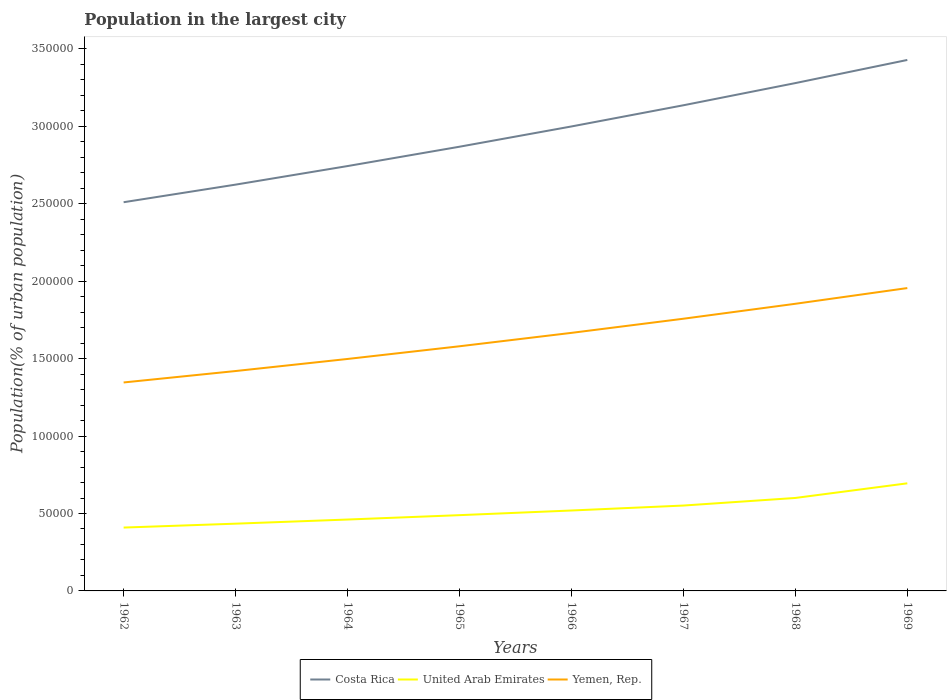Does the line corresponding to United Arab Emirates intersect with the line corresponding to Yemen, Rep.?
Your answer should be compact. No. Is the number of lines equal to the number of legend labels?
Your answer should be compact. Yes. Across all years, what is the maximum population in the largest city in Yemen, Rep.?
Your answer should be compact. 1.35e+05. What is the total population in the largest city in Yemen, Rep. in the graph?
Make the answer very short. -3.20e+04. What is the difference between the highest and the second highest population in the largest city in Yemen, Rep.?
Ensure brevity in your answer.  6.10e+04. What is the difference between the highest and the lowest population in the largest city in United Arab Emirates?
Provide a short and direct response. 3. Is the population in the largest city in Yemen, Rep. strictly greater than the population in the largest city in Costa Rica over the years?
Provide a short and direct response. Yes. How many lines are there?
Your response must be concise. 3. How many years are there in the graph?
Offer a terse response. 8. Does the graph contain any zero values?
Your response must be concise. No. Does the graph contain grids?
Make the answer very short. No. What is the title of the graph?
Make the answer very short. Population in the largest city. What is the label or title of the Y-axis?
Give a very brief answer. Population(% of urban population). What is the Population(% of urban population) of Costa Rica in 1962?
Offer a terse response. 2.51e+05. What is the Population(% of urban population) in United Arab Emirates in 1962?
Give a very brief answer. 4.09e+04. What is the Population(% of urban population) in Yemen, Rep. in 1962?
Your answer should be compact. 1.35e+05. What is the Population(% of urban population) of Costa Rica in 1963?
Provide a succinct answer. 2.62e+05. What is the Population(% of urban population) in United Arab Emirates in 1963?
Provide a short and direct response. 4.34e+04. What is the Population(% of urban population) of Yemen, Rep. in 1963?
Provide a succinct answer. 1.42e+05. What is the Population(% of urban population) of Costa Rica in 1964?
Make the answer very short. 2.74e+05. What is the Population(% of urban population) in United Arab Emirates in 1964?
Offer a very short reply. 4.61e+04. What is the Population(% of urban population) in Yemen, Rep. in 1964?
Provide a short and direct response. 1.50e+05. What is the Population(% of urban population) of Costa Rica in 1965?
Your answer should be compact. 2.87e+05. What is the Population(% of urban population) in United Arab Emirates in 1965?
Keep it short and to the point. 4.89e+04. What is the Population(% of urban population) in Yemen, Rep. in 1965?
Offer a very short reply. 1.58e+05. What is the Population(% of urban population) of Costa Rica in 1966?
Keep it short and to the point. 3.00e+05. What is the Population(% of urban population) in United Arab Emirates in 1966?
Provide a succinct answer. 5.19e+04. What is the Population(% of urban population) in Yemen, Rep. in 1966?
Keep it short and to the point. 1.67e+05. What is the Population(% of urban population) in Costa Rica in 1967?
Your answer should be compact. 3.14e+05. What is the Population(% of urban population) of United Arab Emirates in 1967?
Provide a short and direct response. 5.51e+04. What is the Population(% of urban population) of Yemen, Rep. in 1967?
Ensure brevity in your answer.  1.76e+05. What is the Population(% of urban population) of Costa Rica in 1968?
Your answer should be very brief. 3.28e+05. What is the Population(% of urban population) of United Arab Emirates in 1968?
Provide a short and direct response. 6.00e+04. What is the Population(% of urban population) of Yemen, Rep. in 1968?
Keep it short and to the point. 1.85e+05. What is the Population(% of urban population) in Costa Rica in 1969?
Provide a succinct answer. 3.43e+05. What is the Population(% of urban population) in United Arab Emirates in 1969?
Provide a succinct answer. 6.95e+04. What is the Population(% of urban population) in Yemen, Rep. in 1969?
Your response must be concise. 1.96e+05. Across all years, what is the maximum Population(% of urban population) of Costa Rica?
Provide a short and direct response. 3.43e+05. Across all years, what is the maximum Population(% of urban population) of United Arab Emirates?
Your answer should be very brief. 6.95e+04. Across all years, what is the maximum Population(% of urban population) in Yemen, Rep.?
Your response must be concise. 1.96e+05. Across all years, what is the minimum Population(% of urban population) in Costa Rica?
Provide a short and direct response. 2.51e+05. Across all years, what is the minimum Population(% of urban population) in United Arab Emirates?
Ensure brevity in your answer.  4.09e+04. Across all years, what is the minimum Population(% of urban population) of Yemen, Rep.?
Give a very brief answer. 1.35e+05. What is the total Population(% of urban population) in Costa Rica in the graph?
Make the answer very short. 2.36e+06. What is the total Population(% of urban population) in United Arab Emirates in the graph?
Your response must be concise. 4.16e+05. What is the total Population(% of urban population) of Yemen, Rep. in the graph?
Offer a very short reply. 1.31e+06. What is the difference between the Population(% of urban population) of Costa Rica in 1962 and that in 1963?
Provide a short and direct response. -1.14e+04. What is the difference between the Population(% of urban population) in United Arab Emirates in 1962 and that in 1963?
Your answer should be compact. -2514. What is the difference between the Population(% of urban population) of Yemen, Rep. in 1962 and that in 1963?
Your response must be concise. -7377. What is the difference between the Population(% of urban population) in Costa Rica in 1962 and that in 1964?
Your answer should be compact. -2.33e+04. What is the difference between the Population(% of urban population) in United Arab Emirates in 1962 and that in 1964?
Provide a succinct answer. -5187. What is the difference between the Population(% of urban population) of Yemen, Rep. in 1962 and that in 1964?
Make the answer very short. -1.52e+04. What is the difference between the Population(% of urban population) of Costa Rica in 1962 and that in 1965?
Give a very brief answer. -3.58e+04. What is the difference between the Population(% of urban population) in United Arab Emirates in 1962 and that in 1965?
Provide a succinct answer. -8016. What is the difference between the Population(% of urban population) in Yemen, Rep. in 1962 and that in 1965?
Provide a succinct answer. -2.34e+04. What is the difference between the Population(% of urban population) in Costa Rica in 1962 and that in 1966?
Ensure brevity in your answer.  -4.89e+04. What is the difference between the Population(% of urban population) of United Arab Emirates in 1962 and that in 1966?
Provide a succinct answer. -1.10e+04. What is the difference between the Population(% of urban population) in Yemen, Rep. in 1962 and that in 1966?
Your answer should be compact. -3.20e+04. What is the difference between the Population(% of urban population) of Costa Rica in 1962 and that in 1967?
Give a very brief answer. -6.26e+04. What is the difference between the Population(% of urban population) of United Arab Emirates in 1962 and that in 1967?
Make the answer very short. -1.42e+04. What is the difference between the Population(% of urban population) in Yemen, Rep. in 1962 and that in 1967?
Provide a short and direct response. -4.12e+04. What is the difference between the Population(% of urban population) in Costa Rica in 1962 and that in 1968?
Your answer should be compact. -7.69e+04. What is the difference between the Population(% of urban population) of United Arab Emirates in 1962 and that in 1968?
Provide a short and direct response. -1.91e+04. What is the difference between the Population(% of urban population) in Yemen, Rep. in 1962 and that in 1968?
Ensure brevity in your answer.  -5.08e+04. What is the difference between the Population(% of urban population) in Costa Rica in 1962 and that in 1969?
Your response must be concise. -9.19e+04. What is the difference between the Population(% of urban population) in United Arab Emirates in 1962 and that in 1969?
Offer a very short reply. -2.86e+04. What is the difference between the Population(% of urban population) of Yemen, Rep. in 1962 and that in 1969?
Make the answer very short. -6.10e+04. What is the difference between the Population(% of urban population) of Costa Rica in 1963 and that in 1964?
Your answer should be very brief. -1.20e+04. What is the difference between the Population(% of urban population) of United Arab Emirates in 1963 and that in 1964?
Your response must be concise. -2673. What is the difference between the Population(% of urban population) of Yemen, Rep. in 1963 and that in 1964?
Make the answer very short. -7793. What is the difference between the Population(% of urban population) of Costa Rica in 1963 and that in 1965?
Give a very brief answer. -2.45e+04. What is the difference between the Population(% of urban population) in United Arab Emirates in 1963 and that in 1965?
Your answer should be very brief. -5502. What is the difference between the Population(% of urban population) in Yemen, Rep. in 1963 and that in 1965?
Provide a succinct answer. -1.60e+04. What is the difference between the Population(% of urban population) in Costa Rica in 1963 and that in 1966?
Give a very brief answer. -3.76e+04. What is the difference between the Population(% of urban population) in United Arab Emirates in 1963 and that in 1966?
Provide a succinct answer. -8509. What is the difference between the Population(% of urban population) of Yemen, Rep. in 1963 and that in 1966?
Offer a very short reply. -2.46e+04. What is the difference between the Population(% of urban population) of Costa Rica in 1963 and that in 1967?
Provide a short and direct response. -5.12e+04. What is the difference between the Population(% of urban population) of United Arab Emirates in 1963 and that in 1967?
Provide a short and direct response. -1.17e+04. What is the difference between the Population(% of urban population) in Yemen, Rep. in 1963 and that in 1967?
Your answer should be very brief. -3.38e+04. What is the difference between the Population(% of urban population) of Costa Rica in 1963 and that in 1968?
Ensure brevity in your answer.  -6.56e+04. What is the difference between the Population(% of urban population) of United Arab Emirates in 1963 and that in 1968?
Make the answer very short. -1.66e+04. What is the difference between the Population(% of urban population) of Yemen, Rep. in 1963 and that in 1968?
Give a very brief answer. -4.34e+04. What is the difference between the Population(% of urban population) of Costa Rica in 1963 and that in 1969?
Keep it short and to the point. -8.05e+04. What is the difference between the Population(% of urban population) of United Arab Emirates in 1963 and that in 1969?
Offer a terse response. -2.61e+04. What is the difference between the Population(% of urban population) of Yemen, Rep. in 1963 and that in 1969?
Your response must be concise. -5.36e+04. What is the difference between the Population(% of urban population) in Costa Rica in 1964 and that in 1965?
Ensure brevity in your answer.  -1.25e+04. What is the difference between the Population(% of urban population) in United Arab Emirates in 1964 and that in 1965?
Provide a succinct answer. -2829. What is the difference between the Population(% of urban population) in Yemen, Rep. in 1964 and that in 1965?
Your response must be concise. -8197. What is the difference between the Population(% of urban population) of Costa Rica in 1964 and that in 1966?
Offer a very short reply. -2.56e+04. What is the difference between the Population(% of urban population) in United Arab Emirates in 1964 and that in 1966?
Give a very brief answer. -5836. What is the difference between the Population(% of urban population) in Yemen, Rep. in 1964 and that in 1966?
Keep it short and to the point. -1.69e+04. What is the difference between the Population(% of urban population) in Costa Rica in 1964 and that in 1967?
Keep it short and to the point. -3.93e+04. What is the difference between the Population(% of urban population) of United Arab Emirates in 1964 and that in 1967?
Your response must be concise. -9028. What is the difference between the Population(% of urban population) in Yemen, Rep. in 1964 and that in 1967?
Provide a succinct answer. -2.60e+04. What is the difference between the Population(% of urban population) of Costa Rica in 1964 and that in 1968?
Your answer should be compact. -5.36e+04. What is the difference between the Population(% of urban population) in United Arab Emirates in 1964 and that in 1968?
Make the answer very short. -1.39e+04. What is the difference between the Population(% of urban population) in Yemen, Rep. in 1964 and that in 1968?
Keep it short and to the point. -3.56e+04. What is the difference between the Population(% of urban population) of Costa Rica in 1964 and that in 1969?
Offer a very short reply. -6.85e+04. What is the difference between the Population(% of urban population) of United Arab Emirates in 1964 and that in 1969?
Keep it short and to the point. -2.34e+04. What is the difference between the Population(% of urban population) in Yemen, Rep. in 1964 and that in 1969?
Your response must be concise. -4.58e+04. What is the difference between the Population(% of urban population) in Costa Rica in 1965 and that in 1966?
Give a very brief answer. -1.31e+04. What is the difference between the Population(% of urban population) of United Arab Emirates in 1965 and that in 1966?
Provide a succinct answer. -3007. What is the difference between the Population(% of urban population) in Yemen, Rep. in 1965 and that in 1966?
Your response must be concise. -8658. What is the difference between the Population(% of urban population) of Costa Rica in 1965 and that in 1967?
Offer a terse response. -2.68e+04. What is the difference between the Population(% of urban population) of United Arab Emirates in 1965 and that in 1967?
Offer a terse response. -6199. What is the difference between the Population(% of urban population) in Yemen, Rep. in 1965 and that in 1967?
Ensure brevity in your answer.  -1.78e+04. What is the difference between the Population(% of urban population) of Costa Rica in 1965 and that in 1968?
Your response must be concise. -4.11e+04. What is the difference between the Population(% of urban population) in United Arab Emirates in 1965 and that in 1968?
Your answer should be compact. -1.11e+04. What is the difference between the Population(% of urban population) of Yemen, Rep. in 1965 and that in 1968?
Ensure brevity in your answer.  -2.74e+04. What is the difference between the Population(% of urban population) of Costa Rica in 1965 and that in 1969?
Keep it short and to the point. -5.60e+04. What is the difference between the Population(% of urban population) in United Arab Emirates in 1965 and that in 1969?
Ensure brevity in your answer.  -2.06e+04. What is the difference between the Population(% of urban population) in Yemen, Rep. in 1965 and that in 1969?
Provide a succinct answer. -3.76e+04. What is the difference between the Population(% of urban population) in Costa Rica in 1966 and that in 1967?
Provide a succinct answer. -1.37e+04. What is the difference between the Population(% of urban population) in United Arab Emirates in 1966 and that in 1967?
Your response must be concise. -3192. What is the difference between the Population(% of urban population) of Yemen, Rep. in 1966 and that in 1967?
Your answer should be compact. -9132. What is the difference between the Population(% of urban population) in Costa Rica in 1966 and that in 1968?
Your answer should be very brief. -2.80e+04. What is the difference between the Population(% of urban population) of United Arab Emirates in 1966 and that in 1968?
Your answer should be compact. -8101. What is the difference between the Population(% of urban population) in Yemen, Rep. in 1966 and that in 1968?
Your response must be concise. -1.88e+04. What is the difference between the Population(% of urban population) of Costa Rica in 1966 and that in 1969?
Your answer should be compact. -4.29e+04. What is the difference between the Population(% of urban population) in United Arab Emirates in 1966 and that in 1969?
Ensure brevity in your answer.  -1.75e+04. What is the difference between the Population(% of urban population) in Yemen, Rep. in 1966 and that in 1969?
Keep it short and to the point. -2.89e+04. What is the difference between the Population(% of urban population) in Costa Rica in 1967 and that in 1968?
Give a very brief answer. -1.43e+04. What is the difference between the Population(% of urban population) in United Arab Emirates in 1967 and that in 1968?
Your answer should be very brief. -4909. What is the difference between the Population(% of urban population) in Yemen, Rep. in 1967 and that in 1968?
Make the answer very short. -9647. What is the difference between the Population(% of urban population) in Costa Rica in 1967 and that in 1969?
Your answer should be compact. -2.93e+04. What is the difference between the Population(% of urban population) in United Arab Emirates in 1967 and that in 1969?
Your answer should be very brief. -1.44e+04. What is the difference between the Population(% of urban population) in Yemen, Rep. in 1967 and that in 1969?
Keep it short and to the point. -1.98e+04. What is the difference between the Population(% of urban population) in Costa Rica in 1968 and that in 1969?
Keep it short and to the point. -1.49e+04. What is the difference between the Population(% of urban population) of United Arab Emirates in 1968 and that in 1969?
Your response must be concise. -9448. What is the difference between the Population(% of urban population) of Yemen, Rep. in 1968 and that in 1969?
Ensure brevity in your answer.  -1.01e+04. What is the difference between the Population(% of urban population) of Costa Rica in 1962 and the Population(% of urban population) of United Arab Emirates in 1963?
Your answer should be very brief. 2.08e+05. What is the difference between the Population(% of urban population) in Costa Rica in 1962 and the Population(% of urban population) in Yemen, Rep. in 1963?
Keep it short and to the point. 1.09e+05. What is the difference between the Population(% of urban population) in United Arab Emirates in 1962 and the Population(% of urban population) in Yemen, Rep. in 1963?
Keep it short and to the point. -1.01e+05. What is the difference between the Population(% of urban population) in Costa Rica in 1962 and the Population(% of urban population) in United Arab Emirates in 1964?
Your answer should be compact. 2.05e+05. What is the difference between the Population(% of urban population) in Costa Rica in 1962 and the Population(% of urban population) in Yemen, Rep. in 1964?
Your answer should be very brief. 1.01e+05. What is the difference between the Population(% of urban population) in United Arab Emirates in 1962 and the Population(% of urban population) in Yemen, Rep. in 1964?
Your response must be concise. -1.09e+05. What is the difference between the Population(% of urban population) in Costa Rica in 1962 and the Population(% of urban population) in United Arab Emirates in 1965?
Provide a short and direct response. 2.02e+05. What is the difference between the Population(% of urban population) in Costa Rica in 1962 and the Population(% of urban population) in Yemen, Rep. in 1965?
Give a very brief answer. 9.30e+04. What is the difference between the Population(% of urban population) of United Arab Emirates in 1962 and the Population(% of urban population) of Yemen, Rep. in 1965?
Make the answer very short. -1.17e+05. What is the difference between the Population(% of urban population) in Costa Rica in 1962 and the Population(% of urban population) in United Arab Emirates in 1966?
Keep it short and to the point. 1.99e+05. What is the difference between the Population(% of urban population) in Costa Rica in 1962 and the Population(% of urban population) in Yemen, Rep. in 1966?
Keep it short and to the point. 8.44e+04. What is the difference between the Population(% of urban population) of United Arab Emirates in 1962 and the Population(% of urban population) of Yemen, Rep. in 1966?
Offer a terse response. -1.26e+05. What is the difference between the Population(% of urban population) of Costa Rica in 1962 and the Population(% of urban population) of United Arab Emirates in 1967?
Offer a very short reply. 1.96e+05. What is the difference between the Population(% of urban population) in Costa Rica in 1962 and the Population(% of urban population) in Yemen, Rep. in 1967?
Ensure brevity in your answer.  7.52e+04. What is the difference between the Population(% of urban population) in United Arab Emirates in 1962 and the Population(% of urban population) in Yemen, Rep. in 1967?
Keep it short and to the point. -1.35e+05. What is the difference between the Population(% of urban population) in Costa Rica in 1962 and the Population(% of urban population) in United Arab Emirates in 1968?
Offer a very short reply. 1.91e+05. What is the difference between the Population(% of urban population) of Costa Rica in 1962 and the Population(% of urban population) of Yemen, Rep. in 1968?
Your answer should be very brief. 6.56e+04. What is the difference between the Population(% of urban population) of United Arab Emirates in 1962 and the Population(% of urban population) of Yemen, Rep. in 1968?
Provide a short and direct response. -1.45e+05. What is the difference between the Population(% of urban population) of Costa Rica in 1962 and the Population(% of urban population) of United Arab Emirates in 1969?
Your answer should be very brief. 1.82e+05. What is the difference between the Population(% of urban population) in Costa Rica in 1962 and the Population(% of urban population) in Yemen, Rep. in 1969?
Give a very brief answer. 5.54e+04. What is the difference between the Population(% of urban population) of United Arab Emirates in 1962 and the Population(% of urban population) of Yemen, Rep. in 1969?
Offer a very short reply. -1.55e+05. What is the difference between the Population(% of urban population) of Costa Rica in 1963 and the Population(% of urban population) of United Arab Emirates in 1964?
Offer a very short reply. 2.16e+05. What is the difference between the Population(% of urban population) in Costa Rica in 1963 and the Population(% of urban population) in Yemen, Rep. in 1964?
Your response must be concise. 1.13e+05. What is the difference between the Population(% of urban population) in United Arab Emirates in 1963 and the Population(% of urban population) in Yemen, Rep. in 1964?
Make the answer very short. -1.06e+05. What is the difference between the Population(% of urban population) of Costa Rica in 1963 and the Population(% of urban population) of United Arab Emirates in 1965?
Provide a succinct answer. 2.13e+05. What is the difference between the Population(% of urban population) in Costa Rica in 1963 and the Population(% of urban population) in Yemen, Rep. in 1965?
Give a very brief answer. 1.04e+05. What is the difference between the Population(% of urban population) in United Arab Emirates in 1963 and the Population(% of urban population) in Yemen, Rep. in 1965?
Your response must be concise. -1.15e+05. What is the difference between the Population(% of urban population) of Costa Rica in 1963 and the Population(% of urban population) of United Arab Emirates in 1966?
Your response must be concise. 2.10e+05. What is the difference between the Population(% of urban population) in Costa Rica in 1963 and the Population(% of urban population) in Yemen, Rep. in 1966?
Provide a succinct answer. 9.57e+04. What is the difference between the Population(% of urban population) of United Arab Emirates in 1963 and the Population(% of urban population) of Yemen, Rep. in 1966?
Offer a terse response. -1.23e+05. What is the difference between the Population(% of urban population) of Costa Rica in 1963 and the Population(% of urban population) of United Arab Emirates in 1967?
Make the answer very short. 2.07e+05. What is the difference between the Population(% of urban population) of Costa Rica in 1963 and the Population(% of urban population) of Yemen, Rep. in 1967?
Offer a terse response. 8.66e+04. What is the difference between the Population(% of urban population) in United Arab Emirates in 1963 and the Population(% of urban population) in Yemen, Rep. in 1967?
Make the answer very short. -1.32e+05. What is the difference between the Population(% of urban population) of Costa Rica in 1963 and the Population(% of urban population) of United Arab Emirates in 1968?
Offer a very short reply. 2.02e+05. What is the difference between the Population(% of urban population) of Costa Rica in 1963 and the Population(% of urban population) of Yemen, Rep. in 1968?
Provide a short and direct response. 7.69e+04. What is the difference between the Population(% of urban population) of United Arab Emirates in 1963 and the Population(% of urban population) of Yemen, Rep. in 1968?
Your answer should be compact. -1.42e+05. What is the difference between the Population(% of urban population) in Costa Rica in 1963 and the Population(% of urban population) in United Arab Emirates in 1969?
Provide a succinct answer. 1.93e+05. What is the difference between the Population(% of urban population) in Costa Rica in 1963 and the Population(% of urban population) in Yemen, Rep. in 1969?
Keep it short and to the point. 6.68e+04. What is the difference between the Population(% of urban population) of United Arab Emirates in 1963 and the Population(% of urban population) of Yemen, Rep. in 1969?
Your answer should be very brief. -1.52e+05. What is the difference between the Population(% of urban population) in Costa Rica in 1964 and the Population(% of urban population) in United Arab Emirates in 1965?
Provide a succinct answer. 2.25e+05. What is the difference between the Population(% of urban population) of Costa Rica in 1964 and the Population(% of urban population) of Yemen, Rep. in 1965?
Offer a terse response. 1.16e+05. What is the difference between the Population(% of urban population) of United Arab Emirates in 1964 and the Population(% of urban population) of Yemen, Rep. in 1965?
Make the answer very short. -1.12e+05. What is the difference between the Population(% of urban population) of Costa Rica in 1964 and the Population(% of urban population) of United Arab Emirates in 1966?
Offer a very short reply. 2.22e+05. What is the difference between the Population(% of urban population) in Costa Rica in 1964 and the Population(% of urban population) in Yemen, Rep. in 1966?
Offer a very short reply. 1.08e+05. What is the difference between the Population(% of urban population) in United Arab Emirates in 1964 and the Population(% of urban population) in Yemen, Rep. in 1966?
Make the answer very short. -1.21e+05. What is the difference between the Population(% of urban population) of Costa Rica in 1964 and the Population(% of urban population) of United Arab Emirates in 1967?
Keep it short and to the point. 2.19e+05. What is the difference between the Population(% of urban population) in Costa Rica in 1964 and the Population(% of urban population) in Yemen, Rep. in 1967?
Give a very brief answer. 9.86e+04. What is the difference between the Population(% of urban population) of United Arab Emirates in 1964 and the Population(% of urban population) of Yemen, Rep. in 1967?
Offer a terse response. -1.30e+05. What is the difference between the Population(% of urban population) of Costa Rica in 1964 and the Population(% of urban population) of United Arab Emirates in 1968?
Provide a succinct answer. 2.14e+05. What is the difference between the Population(% of urban population) of Costa Rica in 1964 and the Population(% of urban population) of Yemen, Rep. in 1968?
Give a very brief answer. 8.89e+04. What is the difference between the Population(% of urban population) of United Arab Emirates in 1964 and the Population(% of urban population) of Yemen, Rep. in 1968?
Offer a very short reply. -1.39e+05. What is the difference between the Population(% of urban population) of Costa Rica in 1964 and the Population(% of urban population) of United Arab Emirates in 1969?
Offer a very short reply. 2.05e+05. What is the difference between the Population(% of urban population) of Costa Rica in 1964 and the Population(% of urban population) of Yemen, Rep. in 1969?
Give a very brief answer. 7.88e+04. What is the difference between the Population(% of urban population) in United Arab Emirates in 1964 and the Population(% of urban population) in Yemen, Rep. in 1969?
Give a very brief answer. -1.49e+05. What is the difference between the Population(% of urban population) in Costa Rica in 1965 and the Population(% of urban population) in United Arab Emirates in 1966?
Your answer should be very brief. 2.35e+05. What is the difference between the Population(% of urban population) of Costa Rica in 1965 and the Population(% of urban population) of Yemen, Rep. in 1966?
Ensure brevity in your answer.  1.20e+05. What is the difference between the Population(% of urban population) of United Arab Emirates in 1965 and the Population(% of urban population) of Yemen, Rep. in 1966?
Provide a succinct answer. -1.18e+05. What is the difference between the Population(% of urban population) of Costa Rica in 1965 and the Population(% of urban population) of United Arab Emirates in 1967?
Ensure brevity in your answer.  2.32e+05. What is the difference between the Population(% of urban population) in Costa Rica in 1965 and the Population(% of urban population) in Yemen, Rep. in 1967?
Make the answer very short. 1.11e+05. What is the difference between the Population(% of urban population) in United Arab Emirates in 1965 and the Population(% of urban population) in Yemen, Rep. in 1967?
Provide a short and direct response. -1.27e+05. What is the difference between the Population(% of urban population) of Costa Rica in 1965 and the Population(% of urban population) of United Arab Emirates in 1968?
Ensure brevity in your answer.  2.27e+05. What is the difference between the Population(% of urban population) in Costa Rica in 1965 and the Population(% of urban population) in Yemen, Rep. in 1968?
Keep it short and to the point. 1.01e+05. What is the difference between the Population(% of urban population) of United Arab Emirates in 1965 and the Population(% of urban population) of Yemen, Rep. in 1968?
Offer a terse response. -1.36e+05. What is the difference between the Population(% of urban population) of Costa Rica in 1965 and the Population(% of urban population) of United Arab Emirates in 1969?
Ensure brevity in your answer.  2.17e+05. What is the difference between the Population(% of urban population) in Costa Rica in 1965 and the Population(% of urban population) in Yemen, Rep. in 1969?
Keep it short and to the point. 9.13e+04. What is the difference between the Population(% of urban population) in United Arab Emirates in 1965 and the Population(% of urban population) in Yemen, Rep. in 1969?
Your answer should be very brief. -1.47e+05. What is the difference between the Population(% of urban population) of Costa Rica in 1966 and the Population(% of urban population) of United Arab Emirates in 1967?
Your answer should be compact. 2.45e+05. What is the difference between the Population(% of urban population) in Costa Rica in 1966 and the Population(% of urban population) in Yemen, Rep. in 1967?
Your response must be concise. 1.24e+05. What is the difference between the Population(% of urban population) of United Arab Emirates in 1966 and the Population(% of urban population) of Yemen, Rep. in 1967?
Provide a short and direct response. -1.24e+05. What is the difference between the Population(% of urban population) in Costa Rica in 1966 and the Population(% of urban population) in United Arab Emirates in 1968?
Keep it short and to the point. 2.40e+05. What is the difference between the Population(% of urban population) in Costa Rica in 1966 and the Population(% of urban population) in Yemen, Rep. in 1968?
Your answer should be very brief. 1.15e+05. What is the difference between the Population(% of urban population) in United Arab Emirates in 1966 and the Population(% of urban population) in Yemen, Rep. in 1968?
Your answer should be very brief. -1.33e+05. What is the difference between the Population(% of urban population) of Costa Rica in 1966 and the Population(% of urban population) of United Arab Emirates in 1969?
Offer a very short reply. 2.30e+05. What is the difference between the Population(% of urban population) of Costa Rica in 1966 and the Population(% of urban population) of Yemen, Rep. in 1969?
Keep it short and to the point. 1.04e+05. What is the difference between the Population(% of urban population) in United Arab Emirates in 1966 and the Population(% of urban population) in Yemen, Rep. in 1969?
Your answer should be very brief. -1.44e+05. What is the difference between the Population(% of urban population) of Costa Rica in 1967 and the Population(% of urban population) of United Arab Emirates in 1968?
Offer a terse response. 2.54e+05. What is the difference between the Population(% of urban population) of Costa Rica in 1967 and the Population(% of urban population) of Yemen, Rep. in 1968?
Your answer should be very brief. 1.28e+05. What is the difference between the Population(% of urban population) of United Arab Emirates in 1967 and the Population(% of urban population) of Yemen, Rep. in 1968?
Your response must be concise. -1.30e+05. What is the difference between the Population(% of urban population) in Costa Rica in 1967 and the Population(% of urban population) in United Arab Emirates in 1969?
Your response must be concise. 2.44e+05. What is the difference between the Population(% of urban population) of Costa Rica in 1967 and the Population(% of urban population) of Yemen, Rep. in 1969?
Make the answer very short. 1.18e+05. What is the difference between the Population(% of urban population) in United Arab Emirates in 1967 and the Population(% of urban population) in Yemen, Rep. in 1969?
Ensure brevity in your answer.  -1.40e+05. What is the difference between the Population(% of urban population) in Costa Rica in 1968 and the Population(% of urban population) in United Arab Emirates in 1969?
Make the answer very short. 2.58e+05. What is the difference between the Population(% of urban population) of Costa Rica in 1968 and the Population(% of urban population) of Yemen, Rep. in 1969?
Ensure brevity in your answer.  1.32e+05. What is the difference between the Population(% of urban population) of United Arab Emirates in 1968 and the Population(% of urban population) of Yemen, Rep. in 1969?
Keep it short and to the point. -1.36e+05. What is the average Population(% of urban population) of Costa Rica per year?
Your answer should be compact. 2.95e+05. What is the average Population(% of urban population) in United Arab Emirates per year?
Provide a succinct answer. 5.20e+04. What is the average Population(% of urban population) in Yemen, Rep. per year?
Make the answer very short. 1.63e+05. In the year 1962, what is the difference between the Population(% of urban population) of Costa Rica and Population(% of urban population) of United Arab Emirates?
Your answer should be compact. 2.10e+05. In the year 1962, what is the difference between the Population(% of urban population) in Costa Rica and Population(% of urban population) in Yemen, Rep.?
Provide a succinct answer. 1.16e+05. In the year 1962, what is the difference between the Population(% of urban population) in United Arab Emirates and Population(% of urban population) in Yemen, Rep.?
Offer a very short reply. -9.37e+04. In the year 1963, what is the difference between the Population(% of urban population) of Costa Rica and Population(% of urban population) of United Arab Emirates?
Keep it short and to the point. 2.19e+05. In the year 1963, what is the difference between the Population(% of urban population) in Costa Rica and Population(% of urban population) in Yemen, Rep.?
Provide a short and direct response. 1.20e+05. In the year 1963, what is the difference between the Population(% of urban population) in United Arab Emirates and Population(% of urban population) in Yemen, Rep.?
Keep it short and to the point. -9.86e+04. In the year 1964, what is the difference between the Population(% of urban population) in Costa Rica and Population(% of urban population) in United Arab Emirates?
Provide a short and direct response. 2.28e+05. In the year 1964, what is the difference between the Population(% of urban population) of Costa Rica and Population(% of urban population) of Yemen, Rep.?
Provide a succinct answer. 1.25e+05. In the year 1964, what is the difference between the Population(% of urban population) of United Arab Emirates and Population(% of urban population) of Yemen, Rep.?
Ensure brevity in your answer.  -1.04e+05. In the year 1965, what is the difference between the Population(% of urban population) in Costa Rica and Population(% of urban population) in United Arab Emirates?
Provide a succinct answer. 2.38e+05. In the year 1965, what is the difference between the Population(% of urban population) of Costa Rica and Population(% of urban population) of Yemen, Rep.?
Your response must be concise. 1.29e+05. In the year 1965, what is the difference between the Population(% of urban population) of United Arab Emirates and Population(% of urban population) of Yemen, Rep.?
Your answer should be compact. -1.09e+05. In the year 1966, what is the difference between the Population(% of urban population) of Costa Rica and Population(% of urban population) of United Arab Emirates?
Provide a short and direct response. 2.48e+05. In the year 1966, what is the difference between the Population(% of urban population) of Costa Rica and Population(% of urban population) of Yemen, Rep.?
Ensure brevity in your answer.  1.33e+05. In the year 1966, what is the difference between the Population(% of urban population) of United Arab Emirates and Population(% of urban population) of Yemen, Rep.?
Offer a terse response. -1.15e+05. In the year 1967, what is the difference between the Population(% of urban population) of Costa Rica and Population(% of urban population) of United Arab Emirates?
Offer a terse response. 2.58e+05. In the year 1967, what is the difference between the Population(% of urban population) of Costa Rica and Population(% of urban population) of Yemen, Rep.?
Give a very brief answer. 1.38e+05. In the year 1967, what is the difference between the Population(% of urban population) in United Arab Emirates and Population(% of urban population) in Yemen, Rep.?
Ensure brevity in your answer.  -1.21e+05. In the year 1968, what is the difference between the Population(% of urban population) of Costa Rica and Population(% of urban population) of United Arab Emirates?
Offer a very short reply. 2.68e+05. In the year 1968, what is the difference between the Population(% of urban population) of Costa Rica and Population(% of urban population) of Yemen, Rep.?
Ensure brevity in your answer.  1.43e+05. In the year 1968, what is the difference between the Population(% of urban population) of United Arab Emirates and Population(% of urban population) of Yemen, Rep.?
Offer a terse response. -1.25e+05. In the year 1969, what is the difference between the Population(% of urban population) of Costa Rica and Population(% of urban population) of United Arab Emirates?
Offer a very short reply. 2.73e+05. In the year 1969, what is the difference between the Population(% of urban population) in Costa Rica and Population(% of urban population) in Yemen, Rep.?
Your response must be concise. 1.47e+05. In the year 1969, what is the difference between the Population(% of urban population) in United Arab Emirates and Population(% of urban population) in Yemen, Rep.?
Provide a succinct answer. -1.26e+05. What is the ratio of the Population(% of urban population) in Costa Rica in 1962 to that in 1963?
Provide a succinct answer. 0.96. What is the ratio of the Population(% of urban population) of United Arab Emirates in 1962 to that in 1963?
Ensure brevity in your answer.  0.94. What is the ratio of the Population(% of urban population) of Yemen, Rep. in 1962 to that in 1963?
Provide a short and direct response. 0.95. What is the ratio of the Population(% of urban population) in Costa Rica in 1962 to that in 1964?
Keep it short and to the point. 0.91. What is the ratio of the Population(% of urban population) in United Arab Emirates in 1962 to that in 1964?
Give a very brief answer. 0.89. What is the ratio of the Population(% of urban population) in Yemen, Rep. in 1962 to that in 1964?
Provide a succinct answer. 0.9. What is the ratio of the Population(% of urban population) of United Arab Emirates in 1962 to that in 1965?
Provide a short and direct response. 0.84. What is the ratio of the Population(% of urban population) of Yemen, Rep. in 1962 to that in 1965?
Ensure brevity in your answer.  0.85. What is the ratio of the Population(% of urban population) in Costa Rica in 1962 to that in 1966?
Provide a succinct answer. 0.84. What is the ratio of the Population(% of urban population) in United Arab Emirates in 1962 to that in 1966?
Make the answer very short. 0.79. What is the ratio of the Population(% of urban population) of Yemen, Rep. in 1962 to that in 1966?
Provide a short and direct response. 0.81. What is the ratio of the Population(% of urban population) of Costa Rica in 1962 to that in 1967?
Offer a very short reply. 0.8. What is the ratio of the Population(% of urban population) of United Arab Emirates in 1962 to that in 1967?
Make the answer very short. 0.74. What is the ratio of the Population(% of urban population) in Yemen, Rep. in 1962 to that in 1967?
Keep it short and to the point. 0.77. What is the ratio of the Population(% of urban population) of Costa Rica in 1962 to that in 1968?
Offer a terse response. 0.77. What is the ratio of the Population(% of urban population) of United Arab Emirates in 1962 to that in 1968?
Give a very brief answer. 0.68. What is the ratio of the Population(% of urban population) in Yemen, Rep. in 1962 to that in 1968?
Your response must be concise. 0.73. What is the ratio of the Population(% of urban population) of Costa Rica in 1962 to that in 1969?
Offer a terse response. 0.73. What is the ratio of the Population(% of urban population) of United Arab Emirates in 1962 to that in 1969?
Your answer should be very brief. 0.59. What is the ratio of the Population(% of urban population) of Yemen, Rep. in 1962 to that in 1969?
Offer a very short reply. 0.69. What is the ratio of the Population(% of urban population) of Costa Rica in 1963 to that in 1964?
Offer a terse response. 0.96. What is the ratio of the Population(% of urban population) in United Arab Emirates in 1963 to that in 1964?
Keep it short and to the point. 0.94. What is the ratio of the Population(% of urban population) of Yemen, Rep. in 1963 to that in 1964?
Your answer should be very brief. 0.95. What is the ratio of the Population(% of urban population) in Costa Rica in 1963 to that in 1965?
Ensure brevity in your answer.  0.91. What is the ratio of the Population(% of urban population) of United Arab Emirates in 1963 to that in 1965?
Provide a short and direct response. 0.89. What is the ratio of the Population(% of urban population) of Yemen, Rep. in 1963 to that in 1965?
Give a very brief answer. 0.9. What is the ratio of the Population(% of urban population) of Costa Rica in 1963 to that in 1966?
Ensure brevity in your answer.  0.87. What is the ratio of the Population(% of urban population) of United Arab Emirates in 1963 to that in 1966?
Provide a succinct answer. 0.84. What is the ratio of the Population(% of urban population) in Yemen, Rep. in 1963 to that in 1966?
Give a very brief answer. 0.85. What is the ratio of the Population(% of urban population) in Costa Rica in 1963 to that in 1967?
Your answer should be compact. 0.84. What is the ratio of the Population(% of urban population) of United Arab Emirates in 1963 to that in 1967?
Your response must be concise. 0.79. What is the ratio of the Population(% of urban population) of Yemen, Rep. in 1963 to that in 1967?
Your response must be concise. 0.81. What is the ratio of the Population(% of urban population) of Costa Rica in 1963 to that in 1968?
Your answer should be very brief. 0.8. What is the ratio of the Population(% of urban population) in United Arab Emirates in 1963 to that in 1968?
Offer a very short reply. 0.72. What is the ratio of the Population(% of urban population) in Yemen, Rep. in 1963 to that in 1968?
Provide a succinct answer. 0.77. What is the ratio of the Population(% of urban population) of Costa Rica in 1963 to that in 1969?
Make the answer very short. 0.77. What is the ratio of the Population(% of urban population) of Yemen, Rep. in 1963 to that in 1969?
Offer a very short reply. 0.73. What is the ratio of the Population(% of urban population) in Costa Rica in 1964 to that in 1965?
Ensure brevity in your answer.  0.96. What is the ratio of the Population(% of urban population) of United Arab Emirates in 1964 to that in 1965?
Make the answer very short. 0.94. What is the ratio of the Population(% of urban population) in Yemen, Rep. in 1964 to that in 1965?
Your response must be concise. 0.95. What is the ratio of the Population(% of urban population) in Costa Rica in 1964 to that in 1966?
Offer a terse response. 0.91. What is the ratio of the Population(% of urban population) in United Arab Emirates in 1964 to that in 1966?
Provide a short and direct response. 0.89. What is the ratio of the Population(% of urban population) in Yemen, Rep. in 1964 to that in 1966?
Provide a succinct answer. 0.9. What is the ratio of the Population(% of urban population) of Costa Rica in 1964 to that in 1967?
Your response must be concise. 0.87. What is the ratio of the Population(% of urban population) in United Arab Emirates in 1964 to that in 1967?
Give a very brief answer. 0.84. What is the ratio of the Population(% of urban population) of Yemen, Rep. in 1964 to that in 1967?
Keep it short and to the point. 0.85. What is the ratio of the Population(% of urban population) of Costa Rica in 1964 to that in 1968?
Give a very brief answer. 0.84. What is the ratio of the Population(% of urban population) in United Arab Emirates in 1964 to that in 1968?
Provide a short and direct response. 0.77. What is the ratio of the Population(% of urban population) of Yemen, Rep. in 1964 to that in 1968?
Provide a short and direct response. 0.81. What is the ratio of the Population(% of urban population) in Costa Rica in 1964 to that in 1969?
Provide a short and direct response. 0.8. What is the ratio of the Population(% of urban population) of United Arab Emirates in 1964 to that in 1969?
Your answer should be compact. 0.66. What is the ratio of the Population(% of urban population) of Yemen, Rep. in 1964 to that in 1969?
Give a very brief answer. 0.77. What is the ratio of the Population(% of urban population) of Costa Rica in 1965 to that in 1966?
Offer a very short reply. 0.96. What is the ratio of the Population(% of urban population) in United Arab Emirates in 1965 to that in 1966?
Provide a succinct answer. 0.94. What is the ratio of the Population(% of urban population) of Yemen, Rep. in 1965 to that in 1966?
Offer a very short reply. 0.95. What is the ratio of the Population(% of urban population) of Costa Rica in 1965 to that in 1967?
Provide a succinct answer. 0.91. What is the ratio of the Population(% of urban population) of United Arab Emirates in 1965 to that in 1967?
Your answer should be very brief. 0.89. What is the ratio of the Population(% of urban population) in Yemen, Rep. in 1965 to that in 1967?
Give a very brief answer. 0.9. What is the ratio of the Population(% of urban population) in Costa Rica in 1965 to that in 1968?
Make the answer very short. 0.87. What is the ratio of the Population(% of urban population) of United Arab Emirates in 1965 to that in 1968?
Ensure brevity in your answer.  0.81. What is the ratio of the Population(% of urban population) of Yemen, Rep. in 1965 to that in 1968?
Offer a terse response. 0.85. What is the ratio of the Population(% of urban population) in Costa Rica in 1965 to that in 1969?
Provide a short and direct response. 0.84. What is the ratio of the Population(% of urban population) in United Arab Emirates in 1965 to that in 1969?
Provide a succinct answer. 0.7. What is the ratio of the Population(% of urban population) in Yemen, Rep. in 1965 to that in 1969?
Provide a short and direct response. 0.81. What is the ratio of the Population(% of urban population) in Costa Rica in 1966 to that in 1967?
Offer a terse response. 0.96. What is the ratio of the Population(% of urban population) in United Arab Emirates in 1966 to that in 1967?
Your answer should be compact. 0.94. What is the ratio of the Population(% of urban population) in Yemen, Rep. in 1966 to that in 1967?
Keep it short and to the point. 0.95. What is the ratio of the Population(% of urban population) in Costa Rica in 1966 to that in 1968?
Your response must be concise. 0.91. What is the ratio of the Population(% of urban population) of United Arab Emirates in 1966 to that in 1968?
Your answer should be very brief. 0.87. What is the ratio of the Population(% of urban population) of Yemen, Rep. in 1966 to that in 1968?
Make the answer very short. 0.9. What is the ratio of the Population(% of urban population) in Costa Rica in 1966 to that in 1969?
Make the answer very short. 0.87. What is the ratio of the Population(% of urban population) in United Arab Emirates in 1966 to that in 1969?
Offer a very short reply. 0.75. What is the ratio of the Population(% of urban population) in Yemen, Rep. in 1966 to that in 1969?
Ensure brevity in your answer.  0.85. What is the ratio of the Population(% of urban population) of Costa Rica in 1967 to that in 1968?
Your answer should be compact. 0.96. What is the ratio of the Population(% of urban population) of United Arab Emirates in 1967 to that in 1968?
Offer a very short reply. 0.92. What is the ratio of the Population(% of urban population) in Yemen, Rep. in 1967 to that in 1968?
Your response must be concise. 0.95. What is the ratio of the Population(% of urban population) of Costa Rica in 1967 to that in 1969?
Keep it short and to the point. 0.91. What is the ratio of the Population(% of urban population) of United Arab Emirates in 1967 to that in 1969?
Provide a short and direct response. 0.79. What is the ratio of the Population(% of urban population) in Yemen, Rep. in 1967 to that in 1969?
Make the answer very short. 0.9. What is the ratio of the Population(% of urban population) in Costa Rica in 1968 to that in 1969?
Your response must be concise. 0.96. What is the ratio of the Population(% of urban population) of United Arab Emirates in 1968 to that in 1969?
Keep it short and to the point. 0.86. What is the ratio of the Population(% of urban population) of Yemen, Rep. in 1968 to that in 1969?
Provide a short and direct response. 0.95. What is the difference between the highest and the second highest Population(% of urban population) in Costa Rica?
Your response must be concise. 1.49e+04. What is the difference between the highest and the second highest Population(% of urban population) in United Arab Emirates?
Provide a short and direct response. 9448. What is the difference between the highest and the second highest Population(% of urban population) of Yemen, Rep.?
Your response must be concise. 1.01e+04. What is the difference between the highest and the lowest Population(% of urban population) in Costa Rica?
Offer a terse response. 9.19e+04. What is the difference between the highest and the lowest Population(% of urban population) of United Arab Emirates?
Ensure brevity in your answer.  2.86e+04. What is the difference between the highest and the lowest Population(% of urban population) in Yemen, Rep.?
Keep it short and to the point. 6.10e+04. 